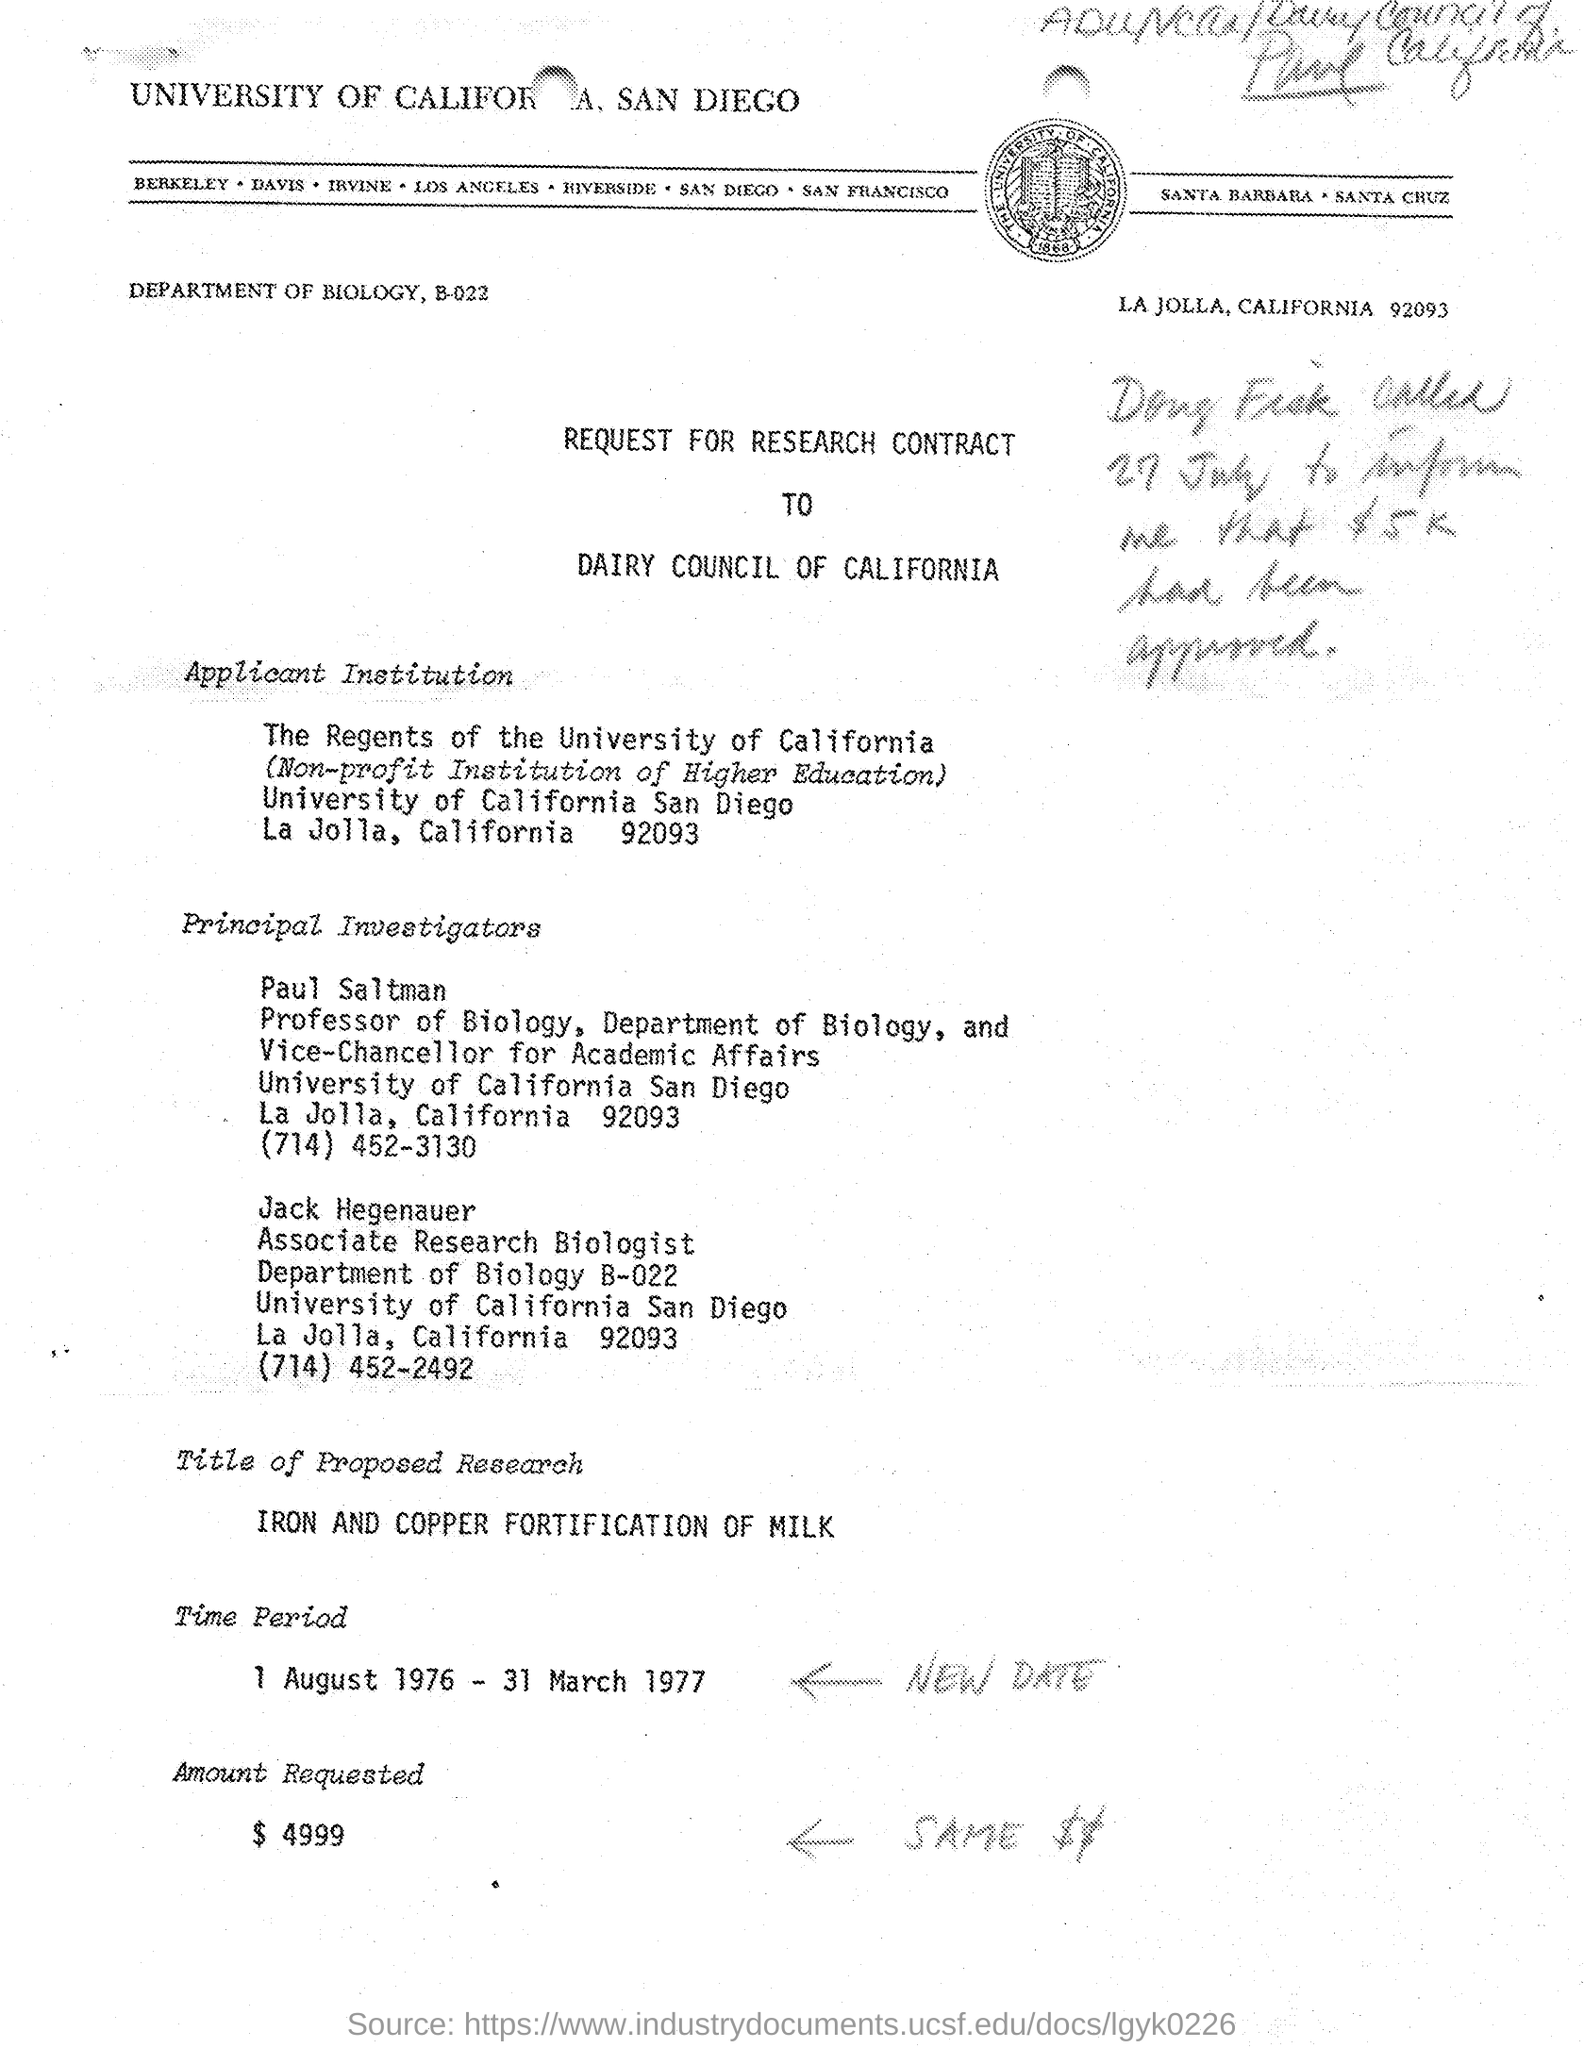Indicate a few pertinent items in this graphic. Jack Hegenauer holds the designation of Associate Research Biologist. The document's header mentions the UNIVERSITY OF CALIFORNIA. SAN DIEGO.. The Vice-Chancellor for Academic Affairs at the University of California, San Diego is Paul Saltman. The amount requested, as specified in the document, is $4,999. The contact number of Paul Saltman mentioned in the document is (714) 452-3130. 